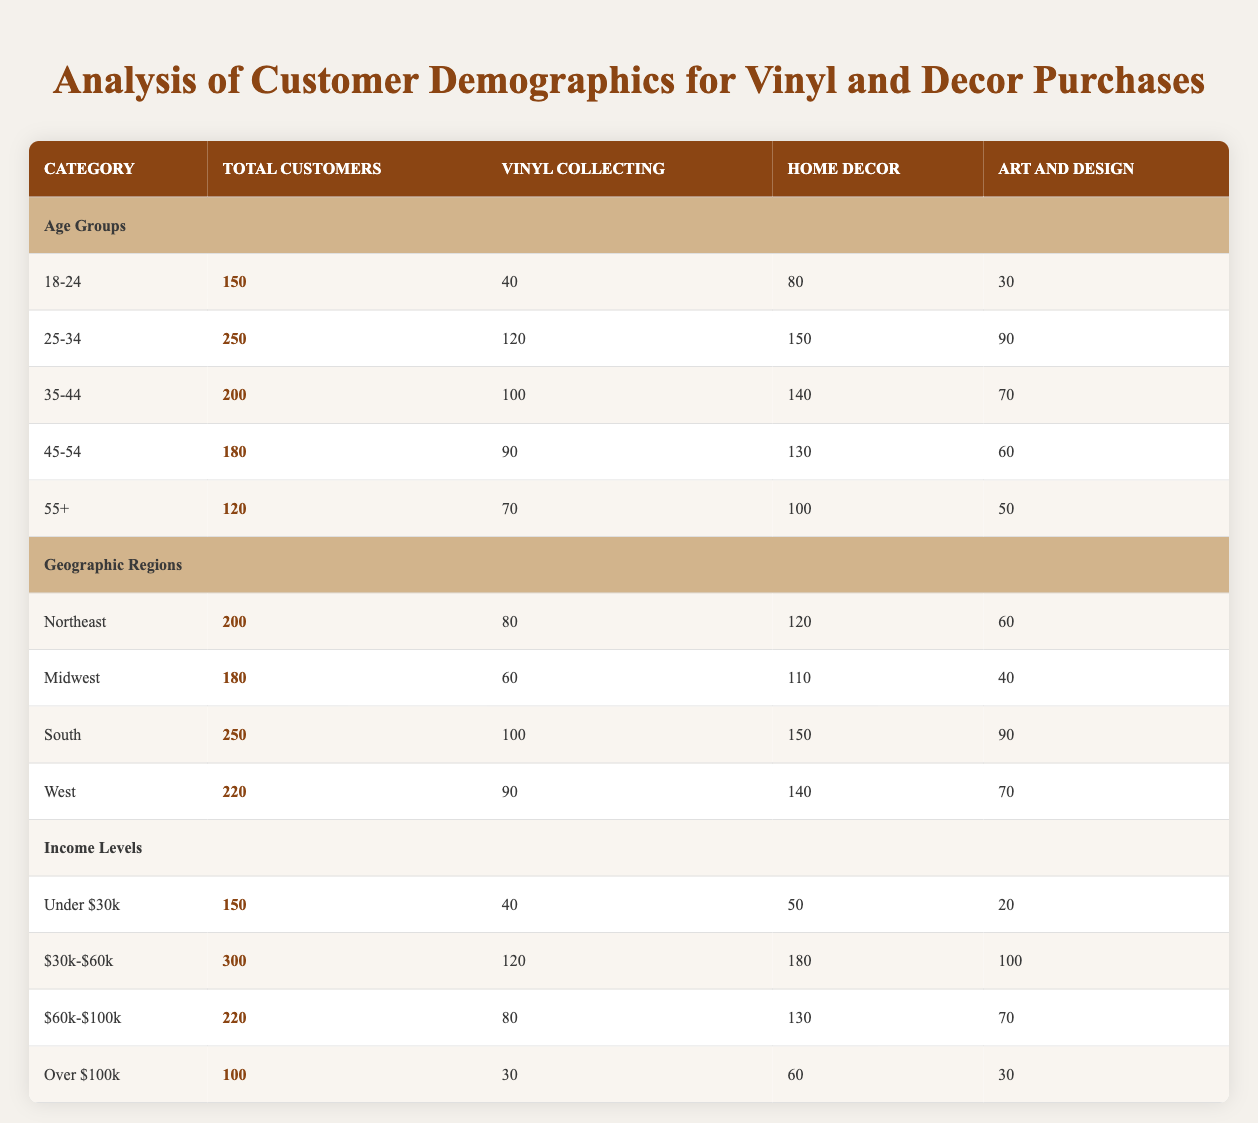What is the total number of customers interested in Home Decor from the 25-34 age group? From the table, it's stated that the total number of customers in the 25-34 age group is 250. The column for Home Decor specifically for this age group shows a value of 150. Therefore, the answer is simply the value from the table.
Answer: 150 Which age group has the highest interest in Vinyl Collecting? Examining the "Vinyl Collecting" column, the highest value is found in the 25-34 age group with 120 customers. The next highest is the 35-44 age group with 100 customers. Thus, the 25-34 age group leads in interest in Vinyl Collecting.
Answer: 25-34 What is the total number of customers who are interested in Art and Design across all income levels? To calculate the total, we need to sum the values from the Art and Design column: 20 (Under $30k) + 100 ($30k-$60k) + 70 ($60k-$100k) + 30 (Over $100k) = 320. Thus, the answer is obtained by adding these four values together.
Answer: 320 Does the South region have more customers interested in Home Decor than the Northeast region? The total number of customers interested in Home Decor for the South region is 150, and for the Northeast region, it’s 120. Since 150 is greater than 120, it confirms that the South region does have more customers interested in Home Decor.
Answer: Yes What is the average number of customers interested in Vinyl Collecting across all age groups? We find the total customers interested in Vinyl Collecting: 40 (18-24) + 120 (25-34) + 100 (35-44) + 90 (45-54) + 70 (55+) = 420 customers. There are 5 age groups, so we divide 420 by 5: 420 / 5 = 84. This calculation gives the average number.
Answer: 84 Which income level has the least number of customers interested in Art and Design? Looking at the Art and Design column for all income levels, Under $30k has 20 customers, $30k-$60k has 100, $60k-$100k has 70, and Over $100k has 30 customers. The least value is 20 customers for the Under $30k income level.
Answer: Under $30k How many total customers are interested in both Home Decor and Vinyl Collecting in the 35-44 age group? In the 35-44 age group, there are 100 customers interested in Vinyl Collecting and 140 customers interested in Home Decor. To find the total, we add these two numbers together: 100 + 140 = 240 customers. This gives the total for this age group.
Answer: 240 Is there a higher interest in Vinyl Collecting from the West region compared to the Midwest region? In the table, the West region shows 90 customers interested in Vinyl Collecting, while the Midwest region has 60 customers. Since 90 is greater than 60, there is indeed a higher interest in Vinyl Collecting from the West region.
Answer: Yes 